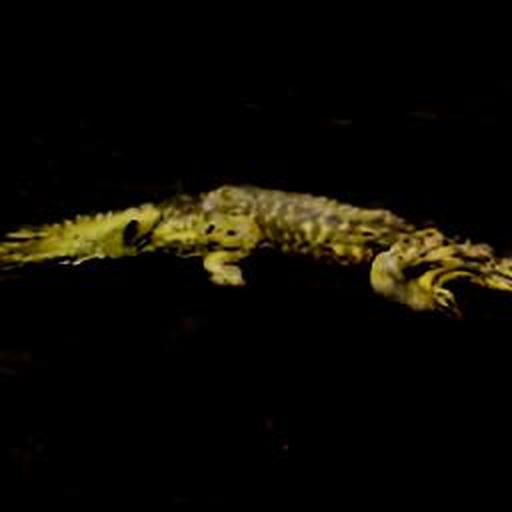Is there anything specifically interesting about this photograph? While the photograph suffers from quality issues, it captures the essence of a crocodile's predatory nature in its natural, likely nocturnal setting, indicated by the darkness surrounding it. This could offer insight into the stealth and patience of such apex predators, although the details aren't as vivid as one might desire. 